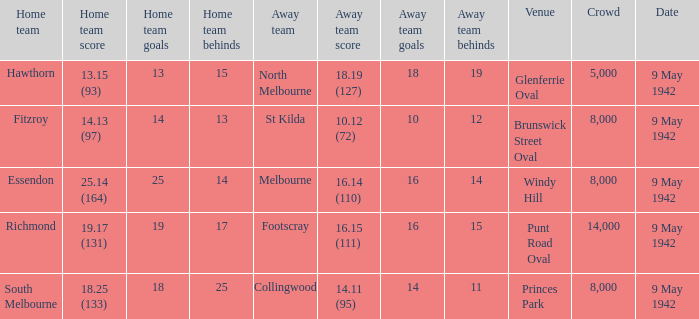How many people attended the game where Footscray was away? 14000.0. 